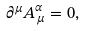<formula> <loc_0><loc_0><loc_500><loc_500>\partial ^ { \mu } A _ { \, \mu } ^ { \alpha } = 0 ,</formula> 